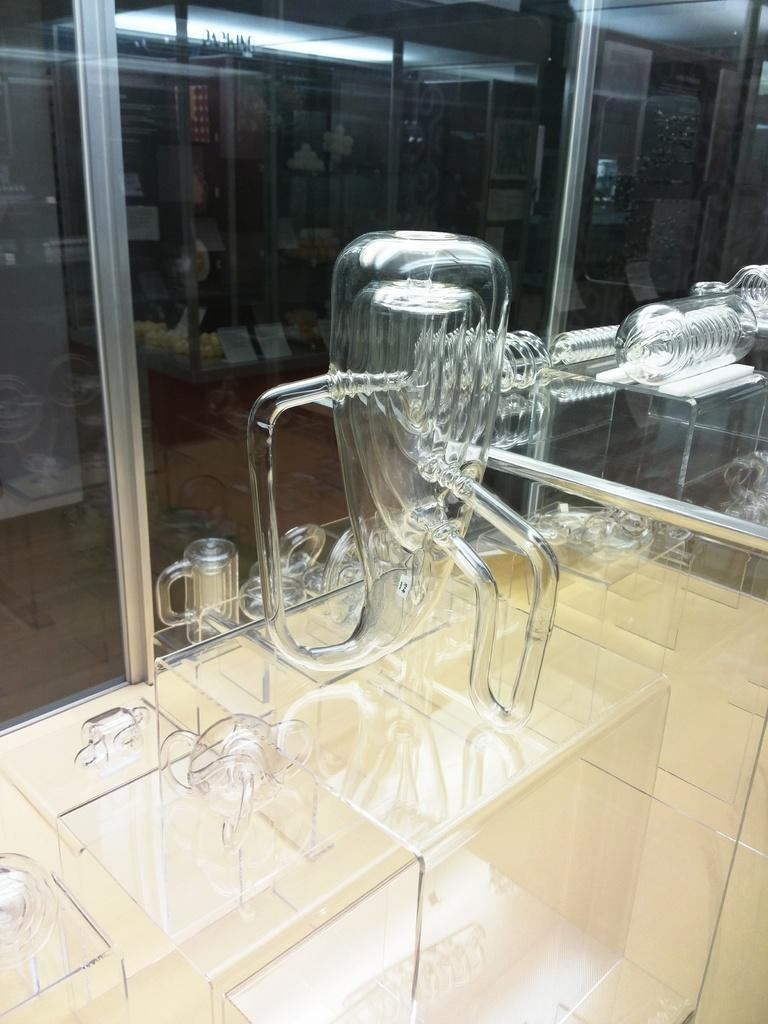What type of utensil is visible in the image? There is a glass utensil in the image. Where is the glass utensil located? The glass utensil is placed on a surface. What can be seen in the background of the image? There is a glass window in the background of the image. What book is the queen reading in the image? There is no queen or book present in the image. What type of toy can be seen on the surface next to the glass utensil? There is no toy present in the image; only the glass utensil and the surface it is placed on are visible. 